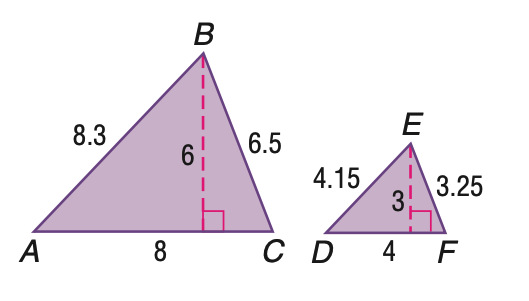Answer the mathemtical geometry problem and directly provide the correct option letter.
Question: Triangle A B C is similar to triangle D E F. Find the scale factor.
Choices: A: \frac { 1 } { 2 } B: \frac { 1 } { 1 } C: \frac { 2 } { 1 } D: \frac { 4 } { 1 } C 